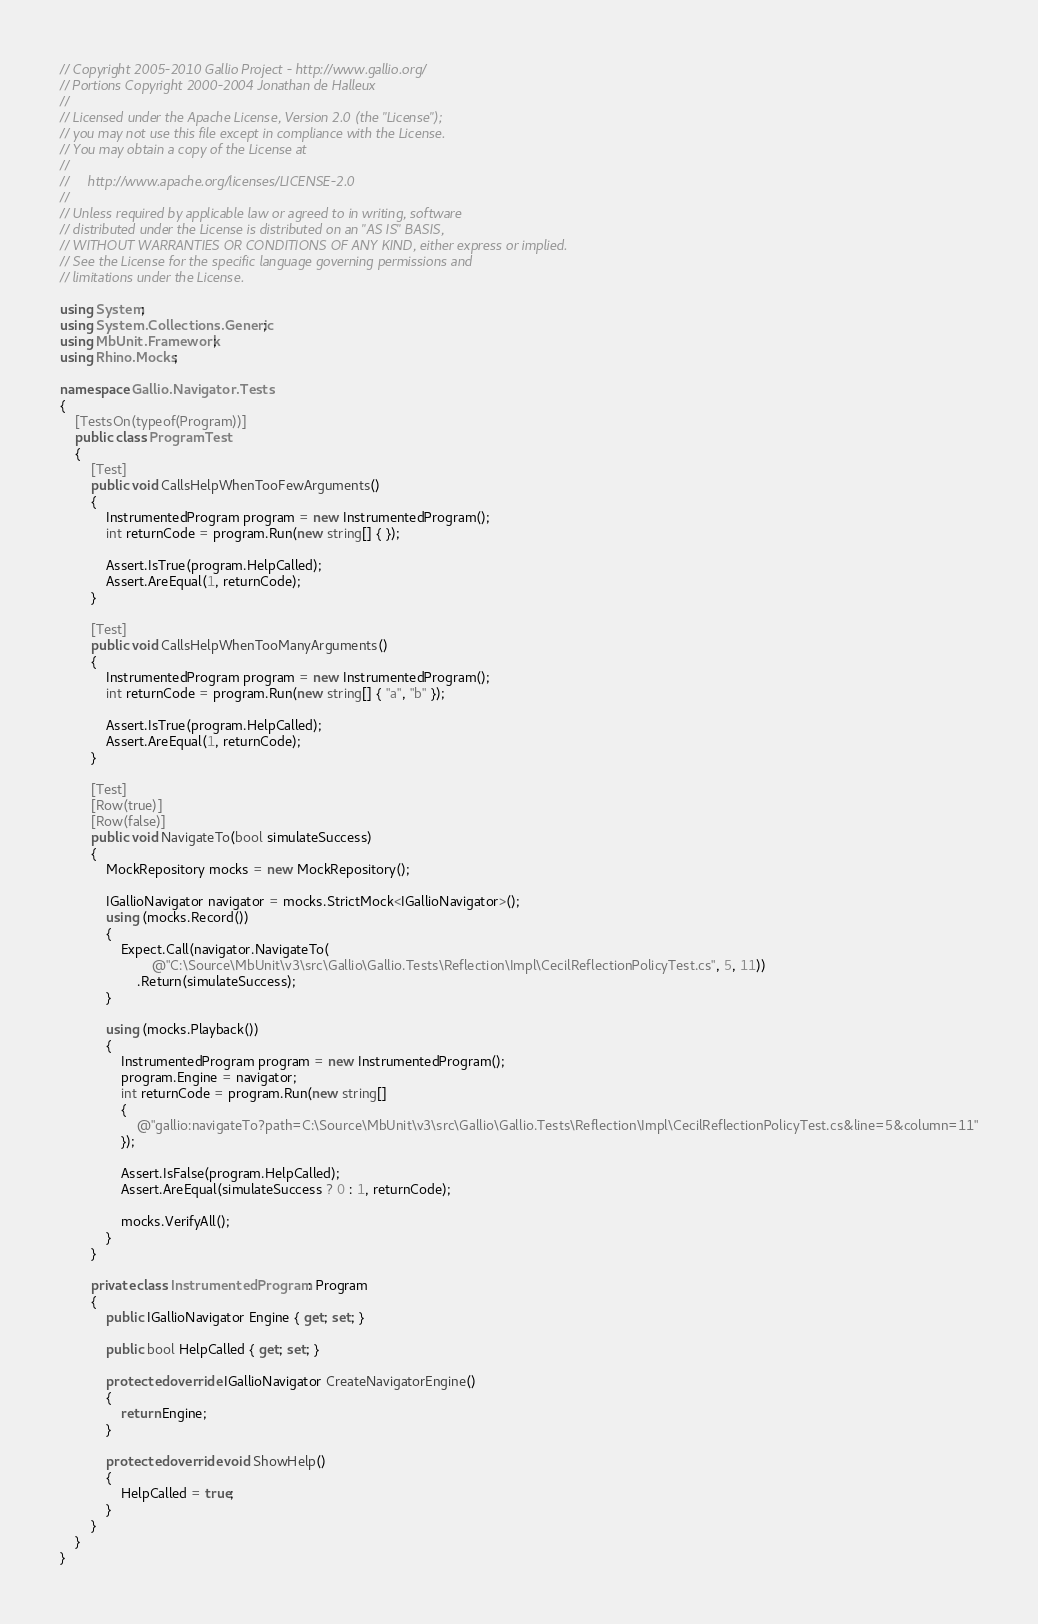<code> <loc_0><loc_0><loc_500><loc_500><_C#_>// Copyright 2005-2010 Gallio Project - http://www.gallio.org/
// Portions Copyright 2000-2004 Jonathan de Halleux
// 
// Licensed under the Apache License, Version 2.0 (the "License");
// you may not use this file except in compliance with the License.
// You may obtain a copy of the License at
// 
//     http://www.apache.org/licenses/LICENSE-2.0
// 
// Unless required by applicable law or agreed to in writing, software
// distributed under the License is distributed on an "AS IS" BASIS,
// WITHOUT WARRANTIES OR CONDITIONS OF ANY KIND, either express or implied.
// See the License for the specific language governing permissions and
// limitations under the License.

using System;
using System.Collections.Generic;
using MbUnit.Framework;
using Rhino.Mocks;

namespace Gallio.Navigator.Tests
{
    [TestsOn(typeof(Program))]
    public class ProgramTest
    {
        [Test]
        public void CallsHelpWhenTooFewArguments()
        {
            InstrumentedProgram program = new InstrumentedProgram();
            int returnCode = program.Run(new string[] { });

            Assert.IsTrue(program.HelpCalled);
            Assert.AreEqual(1, returnCode);
        }

        [Test]
        public void CallsHelpWhenTooManyArguments()
        {
            InstrumentedProgram program = new InstrumentedProgram();
            int returnCode = program.Run(new string[] { "a", "b" });

            Assert.IsTrue(program.HelpCalled);
            Assert.AreEqual(1, returnCode);
        }

        [Test]
        [Row(true)]
        [Row(false)]
        public void NavigateTo(bool simulateSuccess)
        {
            MockRepository mocks = new MockRepository();

            IGallioNavigator navigator = mocks.StrictMock<IGallioNavigator>();
            using (mocks.Record())
            {
                Expect.Call(navigator.NavigateTo(
                        @"C:\Source\MbUnit\v3\src\Gallio\Gallio.Tests\Reflection\Impl\CecilReflectionPolicyTest.cs", 5, 11))
                    .Return(simulateSuccess);
            }

            using (mocks.Playback())
            {
                InstrumentedProgram program = new InstrumentedProgram();
                program.Engine = navigator;
                int returnCode = program.Run(new string[]
                {
                    @"gallio:navigateTo?path=C:\Source\MbUnit\v3\src\Gallio\Gallio.Tests\Reflection\Impl\CecilReflectionPolicyTest.cs&line=5&column=11"
                });

                Assert.IsFalse(program.HelpCalled);
                Assert.AreEqual(simulateSuccess ? 0 : 1, returnCode);

                mocks.VerifyAll();
            }
        }

        private class InstrumentedProgram : Program
        {
            public IGallioNavigator Engine { get; set; }

            public bool HelpCalled { get; set; }

            protected override IGallioNavigator CreateNavigatorEngine()
            {
                return Engine;
            }

            protected override void ShowHelp()
            {
                HelpCalled = true;
            }
        }
    }
}
</code> 